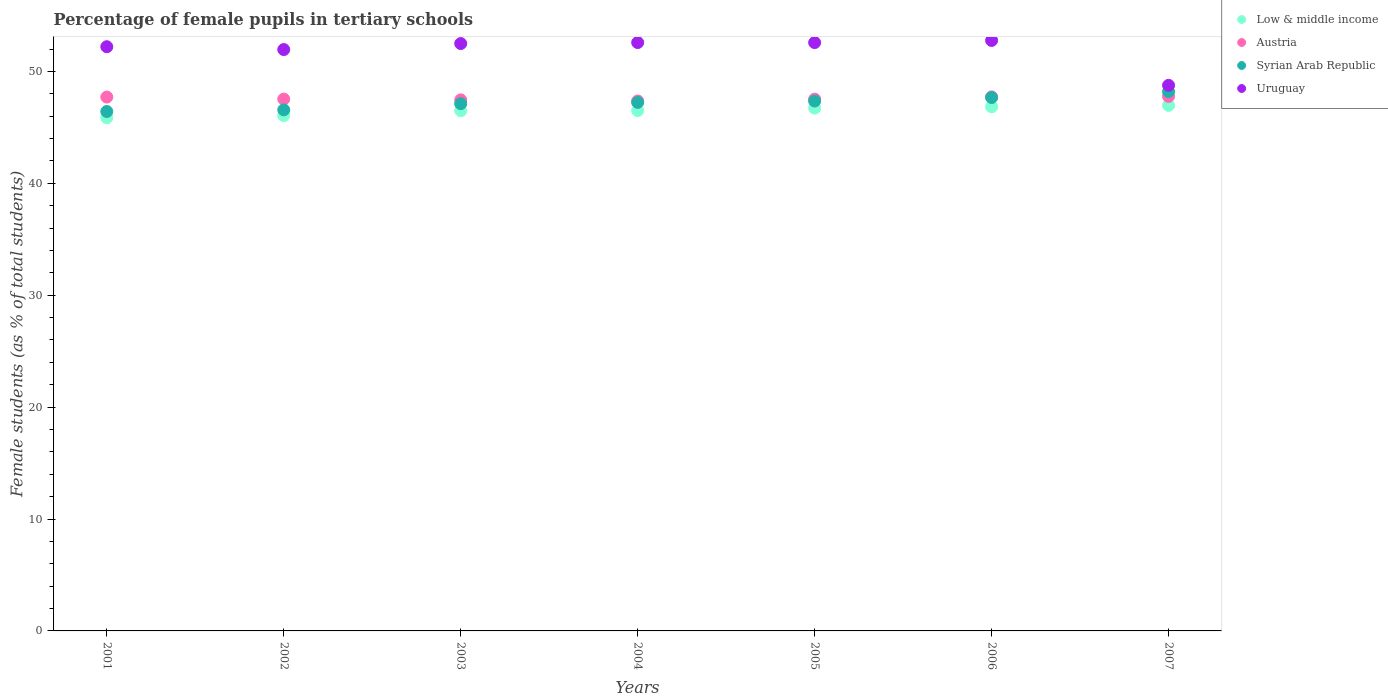Is the number of dotlines equal to the number of legend labels?
Make the answer very short. Yes. What is the percentage of female pupils in tertiary schools in Uruguay in 2005?
Offer a very short reply. 52.58. Across all years, what is the maximum percentage of female pupils in tertiary schools in Low & middle income?
Your answer should be compact. 46.97. Across all years, what is the minimum percentage of female pupils in tertiary schools in Low & middle income?
Provide a succinct answer. 45.87. What is the total percentage of female pupils in tertiary schools in Austria in the graph?
Make the answer very short. 333.08. What is the difference between the percentage of female pupils in tertiary schools in Austria in 2002 and that in 2006?
Make the answer very short. -0.2. What is the difference between the percentage of female pupils in tertiary schools in Syrian Arab Republic in 2006 and the percentage of female pupils in tertiary schools in Uruguay in 2002?
Your answer should be very brief. -4.29. What is the average percentage of female pupils in tertiary schools in Uruguay per year?
Your response must be concise. 51.91. In the year 2001, what is the difference between the percentage of female pupils in tertiary schools in Low & middle income and percentage of female pupils in tertiary schools in Syrian Arab Republic?
Your answer should be compact. -0.55. In how many years, is the percentage of female pupils in tertiary schools in Austria greater than 6 %?
Give a very brief answer. 7. What is the ratio of the percentage of female pupils in tertiary schools in Austria in 2001 to that in 2005?
Your answer should be compact. 1. Is the difference between the percentage of female pupils in tertiary schools in Low & middle income in 2002 and 2004 greater than the difference between the percentage of female pupils in tertiary schools in Syrian Arab Republic in 2002 and 2004?
Offer a very short reply. Yes. What is the difference between the highest and the second highest percentage of female pupils in tertiary schools in Austria?
Provide a short and direct response. 0.04. What is the difference between the highest and the lowest percentage of female pupils in tertiary schools in Syrian Arab Republic?
Give a very brief answer. 1.78. Is it the case that in every year, the sum of the percentage of female pupils in tertiary schools in Low & middle income and percentage of female pupils in tertiary schools in Syrian Arab Republic  is greater than the percentage of female pupils in tertiary schools in Uruguay?
Give a very brief answer. Yes. Is the percentage of female pupils in tertiary schools in Uruguay strictly greater than the percentage of female pupils in tertiary schools in Low & middle income over the years?
Make the answer very short. Yes. Is the percentage of female pupils in tertiary schools in Low & middle income strictly less than the percentage of female pupils in tertiary schools in Syrian Arab Republic over the years?
Keep it short and to the point. Yes. How many dotlines are there?
Give a very brief answer. 4. How many years are there in the graph?
Offer a terse response. 7. What is the difference between two consecutive major ticks on the Y-axis?
Keep it short and to the point. 10. Are the values on the major ticks of Y-axis written in scientific E-notation?
Keep it short and to the point. No. How many legend labels are there?
Offer a very short reply. 4. What is the title of the graph?
Provide a short and direct response. Percentage of female pupils in tertiary schools. Does "Denmark" appear as one of the legend labels in the graph?
Your answer should be very brief. No. What is the label or title of the X-axis?
Your response must be concise. Years. What is the label or title of the Y-axis?
Give a very brief answer. Female students (as % of total students). What is the Female students (as % of total students) of Low & middle income in 2001?
Your response must be concise. 45.87. What is the Female students (as % of total students) in Austria in 2001?
Make the answer very short. 47.71. What is the Female students (as % of total students) of Syrian Arab Republic in 2001?
Your answer should be compact. 46.42. What is the Female students (as % of total students) in Uruguay in 2001?
Offer a terse response. 52.21. What is the Female students (as % of total students) in Low & middle income in 2002?
Provide a succinct answer. 46.06. What is the Female students (as % of total students) of Austria in 2002?
Offer a very short reply. 47.53. What is the Female students (as % of total students) of Syrian Arab Republic in 2002?
Your response must be concise. 46.57. What is the Female students (as % of total students) in Uruguay in 2002?
Ensure brevity in your answer.  51.96. What is the Female students (as % of total students) in Low & middle income in 2003?
Keep it short and to the point. 46.5. What is the Female students (as % of total students) in Austria in 2003?
Provide a succinct answer. 47.46. What is the Female students (as % of total students) of Syrian Arab Republic in 2003?
Ensure brevity in your answer.  47.12. What is the Female students (as % of total students) of Uruguay in 2003?
Give a very brief answer. 52.49. What is the Female students (as % of total students) in Low & middle income in 2004?
Keep it short and to the point. 46.51. What is the Female students (as % of total students) in Austria in 2004?
Your answer should be very brief. 47.36. What is the Female students (as % of total students) of Syrian Arab Republic in 2004?
Make the answer very short. 47.23. What is the Female students (as % of total students) in Uruguay in 2004?
Ensure brevity in your answer.  52.58. What is the Female students (as % of total students) of Low & middle income in 2005?
Your answer should be compact. 46.73. What is the Female students (as % of total students) of Austria in 2005?
Your answer should be very brief. 47.53. What is the Female students (as % of total students) of Syrian Arab Republic in 2005?
Your answer should be very brief. 47.36. What is the Female students (as % of total students) of Uruguay in 2005?
Your response must be concise. 52.58. What is the Female students (as % of total students) of Low & middle income in 2006?
Your answer should be very brief. 46.84. What is the Female students (as % of total students) of Austria in 2006?
Ensure brevity in your answer.  47.72. What is the Female students (as % of total students) of Syrian Arab Republic in 2006?
Give a very brief answer. 47.67. What is the Female students (as % of total students) in Uruguay in 2006?
Your answer should be very brief. 52.77. What is the Female students (as % of total students) of Low & middle income in 2007?
Keep it short and to the point. 46.97. What is the Female students (as % of total students) in Austria in 2007?
Make the answer very short. 47.77. What is the Female students (as % of total students) of Syrian Arab Republic in 2007?
Offer a very short reply. 48.2. What is the Female students (as % of total students) in Uruguay in 2007?
Provide a succinct answer. 48.76. Across all years, what is the maximum Female students (as % of total students) in Low & middle income?
Your answer should be compact. 46.97. Across all years, what is the maximum Female students (as % of total students) of Austria?
Give a very brief answer. 47.77. Across all years, what is the maximum Female students (as % of total students) in Syrian Arab Republic?
Make the answer very short. 48.2. Across all years, what is the maximum Female students (as % of total students) of Uruguay?
Provide a succinct answer. 52.77. Across all years, what is the minimum Female students (as % of total students) in Low & middle income?
Ensure brevity in your answer.  45.87. Across all years, what is the minimum Female students (as % of total students) of Austria?
Offer a terse response. 47.36. Across all years, what is the minimum Female students (as % of total students) of Syrian Arab Republic?
Your response must be concise. 46.42. Across all years, what is the minimum Female students (as % of total students) in Uruguay?
Your response must be concise. 48.76. What is the total Female students (as % of total students) in Low & middle income in the graph?
Your response must be concise. 325.47. What is the total Female students (as % of total students) of Austria in the graph?
Provide a short and direct response. 333.08. What is the total Female students (as % of total students) of Syrian Arab Republic in the graph?
Your response must be concise. 330.56. What is the total Female students (as % of total students) of Uruguay in the graph?
Keep it short and to the point. 363.35. What is the difference between the Female students (as % of total students) in Low & middle income in 2001 and that in 2002?
Ensure brevity in your answer.  -0.19. What is the difference between the Female students (as % of total students) in Austria in 2001 and that in 2002?
Your answer should be compact. 0.18. What is the difference between the Female students (as % of total students) in Syrian Arab Republic in 2001 and that in 2002?
Provide a short and direct response. -0.14. What is the difference between the Female students (as % of total students) of Uruguay in 2001 and that in 2002?
Keep it short and to the point. 0.25. What is the difference between the Female students (as % of total students) of Low & middle income in 2001 and that in 2003?
Ensure brevity in your answer.  -0.63. What is the difference between the Female students (as % of total students) in Austria in 2001 and that in 2003?
Offer a terse response. 0.25. What is the difference between the Female students (as % of total students) of Syrian Arab Republic in 2001 and that in 2003?
Offer a terse response. -0.7. What is the difference between the Female students (as % of total students) in Uruguay in 2001 and that in 2003?
Provide a succinct answer. -0.28. What is the difference between the Female students (as % of total students) in Low & middle income in 2001 and that in 2004?
Give a very brief answer. -0.64. What is the difference between the Female students (as % of total students) of Austria in 2001 and that in 2004?
Keep it short and to the point. 0.35. What is the difference between the Female students (as % of total students) in Syrian Arab Republic in 2001 and that in 2004?
Your answer should be compact. -0.81. What is the difference between the Female students (as % of total students) in Uruguay in 2001 and that in 2004?
Give a very brief answer. -0.37. What is the difference between the Female students (as % of total students) of Low & middle income in 2001 and that in 2005?
Offer a terse response. -0.86. What is the difference between the Female students (as % of total students) in Austria in 2001 and that in 2005?
Your answer should be compact. 0.19. What is the difference between the Female students (as % of total students) of Syrian Arab Republic in 2001 and that in 2005?
Provide a succinct answer. -0.93. What is the difference between the Female students (as % of total students) of Uruguay in 2001 and that in 2005?
Your answer should be very brief. -0.37. What is the difference between the Female students (as % of total students) of Low & middle income in 2001 and that in 2006?
Your answer should be very brief. -0.97. What is the difference between the Female students (as % of total students) in Austria in 2001 and that in 2006?
Keep it short and to the point. -0.01. What is the difference between the Female students (as % of total students) in Syrian Arab Republic in 2001 and that in 2006?
Give a very brief answer. -1.25. What is the difference between the Female students (as % of total students) of Uruguay in 2001 and that in 2006?
Ensure brevity in your answer.  -0.56. What is the difference between the Female students (as % of total students) in Low & middle income in 2001 and that in 2007?
Ensure brevity in your answer.  -1.1. What is the difference between the Female students (as % of total students) of Austria in 2001 and that in 2007?
Offer a terse response. -0.06. What is the difference between the Female students (as % of total students) of Syrian Arab Republic in 2001 and that in 2007?
Keep it short and to the point. -1.78. What is the difference between the Female students (as % of total students) of Uruguay in 2001 and that in 2007?
Provide a short and direct response. 3.45. What is the difference between the Female students (as % of total students) of Low & middle income in 2002 and that in 2003?
Provide a short and direct response. -0.44. What is the difference between the Female students (as % of total students) in Austria in 2002 and that in 2003?
Provide a short and direct response. 0.07. What is the difference between the Female students (as % of total students) in Syrian Arab Republic in 2002 and that in 2003?
Make the answer very short. -0.55. What is the difference between the Female students (as % of total students) of Uruguay in 2002 and that in 2003?
Give a very brief answer. -0.54. What is the difference between the Female students (as % of total students) in Low & middle income in 2002 and that in 2004?
Provide a short and direct response. -0.45. What is the difference between the Female students (as % of total students) in Austria in 2002 and that in 2004?
Your response must be concise. 0.17. What is the difference between the Female students (as % of total students) of Syrian Arab Republic in 2002 and that in 2004?
Give a very brief answer. -0.67. What is the difference between the Female students (as % of total students) of Uruguay in 2002 and that in 2004?
Make the answer very short. -0.63. What is the difference between the Female students (as % of total students) of Low & middle income in 2002 and that in 2005?
Your response must be concise. -0.67. What is the difference between the Female students (as % of total students) of Austria in 2002 and that in 2005?
Offer a very short reply. 0. What is the difference between the Female students (as % of total students) of Syrian Arab Republic in 2002 and that in 2005?
Provide a short and direct response. -0.79. What is the difference between the Female students (as % of total students) of Uruguay in 2002 and that in 2005?
Make the answer very short. -0.62. What is the difference between the Female students (as % of total students) of Low & middle income in 2002 and that in 2006?
Offer a terse response. -0.78. What is the difference between the Female students (as % of total students) in Austria in 2002 and that in 2006?
Give a very brief answer. -0.2. What is the difference between the Female students (as % of total students) of Syrian Arab Republic in 2002 and that in 2006?
Your answer should be compact. -1.1. What is the difference between the Female students (as % of total students) in Uruguay in 2002 and that in 2006?
Ensure brevity in your answer.  -0.82. What is the difference between the Female students (as % of total students) in Low & middle income in 2002 and that in 2007?
Provide a succinct answer. -0.91. What is the difference between the Female students (as % of total students) of Austria in 2002 and that in 2007?
Provide a succinct answer. -0.24. What is the difference between the Female students (as % of total students) of Syrian Arab Republic in 2002 and that in 2007?
Offer a very short reply. -1.63. What is the difference between the Female students (as % of total students) of Uruguay in 2002 and that in 2007?
Provide a succinct answer. 3.2. What is the difference between the Female students (as % of total students) in Low & middle income in 2003 and that in 2004?
Offer a very short reply. -0.01. What is the difference between the Female students (as % of total students) of Austria in 2003 and that in 2004?
Your response must be concise. 0.1. What is the difference between the Female students (as % of total students) in Syrian Arab Republic in 2003 and that in 2004?
Make the answer very short. -0.12. What is the difference between the Female students (as % of total students) in Uruguay in 2003 and that in 2004?
Make the answer very short. -0.09. What is the difference between the Female students (as % of total students) in Low & middle income in 2003 and that in 2005?
Your answer should be very brief. -0.23. What is the difference between the Female students (as % of total students) of Austria in 2003 and that in 2005?
Provide a succinct answer. -0.07. What is the difference between the Female students (as % of total students) in Syrian Arab Republic in 2003 and that in 2005?
Give a very brief answer. -0.24. What is the difference between the Female students (as % of total students) of Uruguay in 2003 and that in 2005?
Your response must be concise. -0.09. What is the difference between the Female students (as % of total students) of Low & middle income in 2003 and that in 2006?
Offer a terse response. -0.35. What is the difference between the Female students (as % of total students) of Austria in 2003 and that in 2006?
Your answer should be compact. -0.27. What is the difference between the Female students (as % of total students) of Syrian Arab Republic in 2003 and that in 2006?
Offer a terse response. -0.55. What is the difference between the Female students (as % of total students) in Uruguay in 2003 and that in 2006?
Provide a succinct answer. -0.28. What is the difference between the Female students (as % of total students) in Low & middle income in 2003 and that in 2007?
Ensure brevity in your answer.  -0.47. What is the difference between the Female students (as % of total students) in Austria in 2003 and that in 2007?
Give a very brief answer. -0.31. What is the difference between the Female students (as % of total students) in Syrian Arab Republic in 2003 and that in 2007?
Your response must be concise. -1.08. What is the difference between the Female students (as % of total students) in Uruguay in 2003 and that in 2007?
Give a very brief answer. 3.73. What is the difference between the Female students (as % of total students) of Low & middle income in 2004 and that in 2005?
Give a very brief answer. -0.22. What is the difference between the Female students (as % of total students) of Austria in 2004 and that in 2005?
Ensure brevity in your answer.  -0.16. What is the difference between the Female students (as % of total students) of Syrian Arab Republic in 2004 and that in 2005?
Your answer should be compact. -0.12. What is the difference between the Female students (as % of total students) of Uruguay in 2004 and that in 2005?
Your response must be concise. 0. What is the difference between the Female students (as % of total students) in Low & middle income in 2004 and that in 2006?
Your answer should be very brief. -0.34. What is the difference between the Female students (as % of total students) in Austria in 2004 and that in 2006?
Your answer should be very brief. -0.36. What is the difference between the Female students (as % of total students) in Syrian Arab Republic in 2004 and that in 2006?
Make the answer very short. -0.43. What is the difference between the Female students (as % of total students) of Uruguay in 2004 and that in 2006?
Your answer should be compact. -0.19. What is the difference between the Female students (as % of total students) in Low & middle income in 2004 and that in 2007?
Provide a short and direct response. -0.46. What is the difference between the Female students (as % of total students) in Austria in 2004 and that in 2007?
Provide a short and direct response. -0.4. What is the difference between the Female students (as % of total students) in Syrian Arab Republic in 2004 and that in 2007?
Offer a terse response. -0.97. What is the difference between the Female students (as % of total students) of Uruguay in 2004 and that in 2007?
Offer a terse response. 3.82. What is the difference between the Female students (as % of total students) in Low & middle income in 2005 and that in 2006?
Provide a short and direct response. -0.12. What is the difference between the Female students (as % of total students) of Austria in 2005 and that in 2006?
Your answer should be very brief. -0.2. What is the difference between the Female students (as % of total students) of Syrian Arab Republic in 2005 and that in 2006?
Ensure brevity in your answer.  -0.31. What is the difference between the Female students (as % of total students) of Uruguay in 2005 and that in 2006?
Provide a short and direct response. -0.19. What is the difference between the Female students (as % of total students) in Low & middle income in 2005 and that in 2007?
Keep it short and to the point. -0.24. What is the difference between the Female students (as % of total students) of Austria in 2005 and that in 2007?
Your answer should be very brief. -0.24. What is the difference between the Female students (as % of total students) of Syrian Arab Republic in 2005 and that in 2007?
Your response must be concise. -0.84. What is the difference between the Female students (as % of total students) in Uruguay in 2005 and that in 2007?
Ensure brevity in your answer.  3.82. What is the difference between the Female students (as % of total students) of Low & middle income in 2006 and that in 2007?
Your response must be concise. -0.12. What is the difference between the Female students (as % of total students) in Austria in 2006 and that in 2007?
Your answer should be compact. -0.04. What is the difference between the Female students (as % of total students) in Syrian Arab Republic in 2006 and that in 2007?
Offer a very short reply. -0.53. What is the difference between the Female students (as % of total students) of Uruguay in 2006 and that in 2007?
Ensure brevity in your answer.  4.01. What is the difference between the Female students (as % of total students) in Low & middle income in 2001 and the Female students (as % of total students) in Austria in 2002?
Provide a succinct answer. -1.66. What is the difference between the Female students (as % of total students) in Low & middle income in 2001 and the Female students (as % of total students) in Syrian Arab Republic in 2002?
Offer a terse response. -0.7. What is the difference between the Female students (as % of total students) in Low & middle income in 2001 and the Female students (as % of total students) in Uruguay in 2002?
Give a very brief answer. -6.09. What is the difference between the Female students (as % of total students) in Austria in 2001 and the Female students (as % of total students) in Syrian Arab Republic in 2002?
Make the answer very short. 1.14. What is the difference between the Female students (as % of total students) in Austria in 2001 and the Female students (as % of total students) in Uruguay in 2002?
Provide a succinct answer. -4.24. What is the difference between the Female students (as % of total students) in Syrian Arab Republic in 2001 and the Female students (as % of total students) in Uruguay in 2002?
Offer a terse response. -5.53. What is the difference between the Female students (as % of total students) of Low & middle income in 2001 and the Female students (as % of total students) of Austria in 2003?
Give a very brief answer. -1.59. What is the difference between the Female students (as % of total students) of Low & middle income in 2001 and the Female students (as % of total students) of Syrian Arab Republic in 2003?
Offer a very short reply. -1.25. What is the difference between the Female students (as % of total students) of Low & middle income in 2001 and the Female students (as % of total students) of Uruguay in 2003?
Your answer should be compact. -6.62. What is the difference between the Female students (as % of total students) of Austria in 2001 and the Female students (as % of total students) of Syrian Arab Republic in 2003?
Provide a succinct answer. 0.59. What is the difference between the Female students (as % of total students) in Austria in 2001 and the Female students (as % of total students) in Uruguay in 2003?
Offer a terse response. -4.78. What is the difference between the Female students (as % of total students) in Syrian Arab Republic in 2001 and the Female students (as % of total students) in Uruguay in 2003?
Offer a terse response. -6.07. What is the difference between the Female students (as % of total students) in Low & middle income in 2001 and the Female students (as % of total students) in Austria in 2004?
Offer a terse response. -1.49. What is the difference between the Female students (as % of total students) of Low & middle income in 2001 and the Female students (as % of total students) of Syrian Arab Republic in 2004?
Provide a short and direct response. -1.36. What is the difference between the Female students (as % of total students) of Low & middle income in 2001 and the Female students (as % of total students) of Uruguay in 2004?
Offer a terse response. -6.71. What is the difference between the Female students (as % of total students) of Austria in 2001 and the Female students (as % of total students) of Syrian Arab Republic in 2004?
Your answer should be very brief. 0.48. What is the difference between the Female students (as % of total students) of Austria in 2001 and the Female students (as % of total students) of Uruguay in 2004?
Ensure brevity in your answer.  -4.87. What is the difference between the Female students (as % of total students) of Syrian Arab Republic in 2001 and the Female students (as % of total students) of Uruguay in 2004?
Offer a terse response. -6.16. What is the difference between the Female students (as % of total students) of Low & middle income in 2001 and the Female students (as % of total students) of Austria in 2005?
Provide a succinct answer. -1.66. What is the difference between the Female students (as % of total students) in Low & middle income in 2001 and the Female students (as % of total students) in Syrian Arab Republic in 2005?
Ensure brevity in your answer.  -1.49. What is the difference between the Female students (as % of total students) of Low & middle income in 2001 and the Female students (as % of total students) of Uruguay in 2005?
Offer a terse response. -6.71. What is the difference between the Female students (as % of total students) of Austria in 2001 and the Female students (as % of total students) of Syrian Arab Republic in 2005?
Make the answer very short. 0.36. What is the difference between the Female students (as % of total students) of Austria in 2001 and the Female students (as % of total students) of Uruguay in 2005?
Provide a succinct answer. -4.87. What is the difference between the Female students (as % of total students) in Syrian Arab Republic in 2001 and the Female students (as % of total students) in Uruguay in 2005?
Make the answer very short. -6.16. What is the difference between the Female students (as % of total students) in Low & middle income in 2001 and the Female students (as % of total students) in Austria in 2006?
Make the answer very short. -1.86. What is the difference between the Female students (as % of total students) of Low & middle income in 2001 and the Female students (as % of total students) of Syrian Arab Republic in 2006?
Offer a terse response. -1.8. What is the difference between the Female students (as % of total students) in Low & middle income in 2001 and the Female students (as % of total students) in Uruguay in 2006?
Keep it short and to the point. -6.9. What is the difference between the Female students (as % of total students) of Austria in 2001 and the Female students (as % of total students) of Syrian Arab Republic in 2006?
Give a very brief answer. 0.04. What is the difference between the Female students (as % of total students) of Austria in 2001 and the Female students (as % of total students) of Uruguay in 2006?
Your answer should be compact. -5.06. What is the difference between the Female students (as % of total students) in Syrian Arab Republic in 2001 and the Female students (as % of total students) in Uruguay in 2006?
Give a very brief answer. -6.35. What is the difference between the Female students (as % of total students) of Low & middle income in 2001 and the Female students (as % of total students) of Austria in 2007?
Offer a terse response. -1.9. What is the difference between the Female students (as % of total students) of Low & middle income in 2001 and the Female students (as % of total students) of Syrian Arab Republic in 2007?
Make the answer very short. -2.33. What is the difference between the Female students (as % of total students) in Low & middle income in 2001 and the Female students (as % of total students) in Uruguay in 2007?
Give a very brief answer. -2.89. What is the difference between the Female students (as % of total students) of Austria in 2001 and the Female students (as % of total students) of Syrian Arab Republic in 2007?
Your answer should be compact. -0.49. What is the difference between the Female students (as % of total students) of Austria in 2001 and the Female students (as % of total students) of Uruguay in 2007?
Keep it short and to the point. -1.05. What is the difference between the Female students (as % of total students) in Syrian Arab Republic in 2001 and the Female students (as % of total students) in Uruguay in 2007?
Make the answer very short. -2.34. What is the difference between the Female students (as % of total students) in Low & middle income in 2002 and the Female students (as % of total students) in Austria in 2003?
Your response must be concise. -1.4. What is the difference between the Female students (as % of total students) of Low & middle income in 2002 and the Female students (as % of total students) of Syrian Arab Republic in 2003?
Provide a succinct answer. -1.06. What is the difference between the Female students (as % of total students) in Low & middle income in 2002 and the Female students (as % of total students) in Uruguay in 2003?
Your answer should be compact. -6.43. What is the difference between the Female students (as % of total students) in Austria in 2002 and the Female students (as % of total students) in Syrian Arab Republic in 2003?
Provide a short and direct response. 0.41. What is the difference between the Female students (as % of total students) of Austria in 2002 and the Female students (as % of total students) of Uruguay in 2003?
Ensure brevity in your answer.  -4.96. What is the difference between the Female students (as % of total students) in Syrian Arab Republic in 2002 and the Female students (as % of total students) in Uruguay in 2003?
Your answer should be very brief. -5.93. What is the difference between the Female students (as % of total students) in Low & middle income in 2002 and the Female students (as % of total students) in Austria in 2004?
Your answer should be compact. -1.3. What is the difference between the Female students (as % of total students) of Low & middle income in 2002 and the Female students (as % of total students) of Syrian Arab Republic in 2004?
Your response must be concise. -1.17. What is the difference between the Female students (as % of total students) in Low & middle income in 2002 and the Female students (as % of total students) in Uruguay in 2004?
Keep it short and to the point. -6.52. What is the difference between the Female students (as % of total students) of Austria in 2002 and the Female students (as % of total students) of Syrian Arab Republic in 2004?
Make the answer very short. 0.3. What is the difference between the Female students (as % of total students) in Austria in 2002 and the Female students (as % of total students) in Uruguay in 2004?
Your answer should be very brief. -5.05. What is the difference between the Female students (as % of total students) in Syrian Arab Republic in 2002 and the Female students (as % of total students) in Uruguay in 2004?
Your answer should be very brief. -6.02. What is the difference between the Female students (as % of total students) of Low & middle income in 2002 and the Female students (as % of total students) of Austria in 2005?
Offer a terse response. -1.47. What is the difference between the Female students (as % of total students) in Low & middle income in 2002 and the Female students (as % of total students) in Syrian Arab Republic in 2005?
Provide a short and direct response. -1.3. What is the difference between the Female students (as % of total students) in Low & middle income in 2002 and the Female students (as % of total students) in Uruguay in 2005?
Your answer should be very brief. -6.52. What is the difference between the Female students (as % of total students) in Austria in 2002 and the Female students (as % of total students) in Syrian Arab Republic in 2005?
Offer a terse response. 0.17. What is the difference between the Female students (as % of total students) of Austria in 2002 and the Female students (as % of total students) of Uruguay in 2005?
Keep it short and to the point. -5.05. What is the difference between the Female students (as % of total students) in Syrian Arab Republic in 2002 and the Female students (as % of total students) in Uruguay in 2005?
Your response must be concise. -6.01. What is the difference between the Female students (as % of total students) in Low & middle income in 2002 and the Female students (as % of total students) in Austria in 2006?
Offer a very short reply. -1.67. What is the difference between the Female students (as % of total students) in Low & middle income in 2002 and the Female students (as % of total students) in Syrian Arab Republic in 2006?
Keep it short and to the point. -1.61. What is the difference between the Female students (as % of total students) of Low & middle income in 2002 and the Female students (as % of total students) of Uruguay in 2006?
Keep it short and to the point. -6.71. What is the difference between the Female students (as % of total students) in Austria in 2002 and the Female students (as % of total students) in Syrian Arab Republic in 2006?
Your answer should be compact. -0.14. What is the difference between the Female students (as % of total students) in Austria in 2002 and the Female students (as % of total students) in Uruguay in 2006?
Keep it short and to the point. -5.24. What is the difference between the Female students (as % of total students) in Syrian Arab Republic in 2002 and the Female students (as % of total students) in Uruguay in 2006?
Your answer should be compact. -6.21. What is the difference between the Female students (as % of total students) of Low & middle income in 2002 and the Female students (as % of total students) of Austria in 2007?
Your answer should be compact. -1.71. What is the difference between the Female students (as % of total students) of Low & middle income in 2002 and the Female students (as % of total students) of Syrian Arab Republic in 2007?
Offer a terse response. -2.14. What is the difference between the Female students (as % of total students) of Low & middle income in 2002 and the Female students (as % of total students) of Uruguay in 2007?
Keep it short and to the point. -2.7. What is the difference between the Female students (as % of total students) of Austria in 2002 and the Female students (as % of total students) of Syrian Arab Republic in 2007?
Provide a succinct answer. -0.67. What is the difference between the Female students (as % of total students) in Austria in 2002 and the Female students (as % of total students) in Uruguay in 2007?
Provide a short and direct response. -1.23. What is the difference between the Female students (as % of total students) in Syrian Arab Republic in 2002 and the Female students (as % of total students) in Uruguay in 2007?
Offer a terse response. -2.19. What is the difference between the Female students (as % of total students) in Low & middle income in 2003 and the Female students (as % of total students) in Austria in 2004?
Provide a short and direct response. -0.87. What is the difference between the Female students (as % of total students) in Low & middle income in 2003 and the Female students (as % of total students) in Syrian Arab Republic in 2004?
Provide a short and direct response. -0.74. What is the difference between the Female students (as % of total students) of Low & middle income in 2003 and the Female students (as % of total students) of Uruguay in 2004?
Keep it short and to the point. -6.09. What is the difference between the Female students (as % of total students) of Austria in 2003 and the Female students (as % of total students) of Syrian Arab Republic in 2004?
Your response must be concise. 0.23. What is the difference between the Female students (as % of total students) of Austria in 2003 and the Female students (as % of total students) of Uruguay in 2004?
Make the answer very short. -5.12. What is the difference between the Female students (as % of total students) of Syrian Arab Republic in 2003 and the Female students (as % of total students) of Uruguay in 2004?
Give a very brief answer. -5.47. What is the difference between the Female students (as % of total students) in Low & middle income in 2003 and the Female students (as % of total students) in Austria in 2005?
Provide a succinct answer. -1.03. What is the difference between the Female students (as % of total students) in Low & middle income in 2003 and the Female students (as % of total students) in Syrian Arab Republic in 2005?
Your answer should be very brief. -0.86. What is the difference between the Female students (as % of total students) in Low & middle income in 2003 and the Female students (as % of total students) in Uruguay in 2005?
Your answer should be very brief. -6.08. What is the difference between the Female students (as % of total students) in Austria in 2003 and the Female students (as % of total students) in Syrian Arab Republic in 2005?
Your answer should be very brief. 0.1. What is the difference between the Female students (as % of total students) in Austria in 2003 and the Female students (as % of total students) in Uruguay in 2005?
Offer a terse response. -5.12. What is the difference between the Female students (as % of total students) in Syrian Arab Republic in 2003 and the Female students (as % of total students) in Uruguay in 2005?
Make the answer very short. -5.46. What is the difference between the Female students (as % of total students) in Low & middle income in 2003 and the Female students (as % of total students) in Austria in 2006?
Your response must be concise. -1.23. What is the difference between the Female students (as % of total students) in Low & middle income in 2003 and the Female students (as % of total students) in Syrian Arab Republic in 2006?
Your answer should be very brief. -1.17. What is the difference between the Female students (as % of total students) of Low & middle income in 2003 and the Female students (as % of total students) of Uruguay in 2006?
Your answer should be very brief. -6.28. What is the difference between the Female students (as % of total students) of Austria in 2003 and the Female students (as % of total students) of Syrian Arab Republic in 2006?
Your response must be concise. -0.21. What is the difference between the Female students (as % of total students) of Austria in 2003 and the Female students (as % of total students) of Uruguay in 2006?
Your answer should be very brief. -5.31. What is the difference between the Female students (as % of total students) in Syrian Arab Republic in 2003 and the Female students (as % of total students) in Uruguay in 2006?
Provide a short and direct response. -5.65. What is the difference between the Female students (as % of total students) of Low & middle income in 2003 and the Female students (as % of total students) of Austria in 2007?
Your answer should be very brief. -1.27. What is the difference between the Female students (as % of total students) in Low & middle income in 2003 and the Female students (as % of total students) in Syrian Arab Republic in 2007?
Your answer should be very brief. -1.7. What is the difference between the Female students (as % of total students) in Low & middle income in 2003 and the Female students (as % of total students) in Uruguay in 2007?
Give a very brief answer. -2.26. What is the difference between the Female students (as % of total students) in Austria in 2003 and the Female students (as % of total students) in Syrian Arab Republic in 2007?
Offer a very short reply. -0.74. What is the difference between the Female students (as % of total students) of Austria in 2003 and the Female students (as % of total students) of Uruguay in 2007?
Offer a terse response. -1.3. What is the difference between the Female students (as % of total students) of Syrian Arab Republic in 2003 and the Female students (as % of total students) of Uruguay in 2007?
Make the answer very short. -1.64. What is the difference between the Female students (as % of total students) in Low & middle income in 2004 and the Female students (as % of total students) in Austria in 2005?
Give a very brief answer. -1.02. What is the difference between the Female students (as % of total students) of Low & middle income in 2004 and the Female students (as % of total students) of Syrian Arab Republic in 2005?
Your response must be concise. -0.85. What is the difference between the Female students (as % of total students) of Low & middle income in 2004 and the Female students (as % of total students) of Uruguay in 2005?
Offer a terse response. -6.07. What is the difference between the Female students (as % of total students) in Austria in 2004 and the Female students (as % of total students) in Syrian Arab Republic in 2005?
Offer a terse response. 0.01. What is the difference between the Female students (as % of total students) of Austria in 2004 and the Female students (as % of total students) of Uruguay in 2005?
Ensure brevity in your answer.  -5.22. What is the difference between the Female students (as % of total students) in Syrian Arab Republic in 2004 and the Female students (as % of total students) in Uruguay in 2005?
Your response must be concise. -5.35. What is the difference between the Female students (as % of total students) of Low & middle income in 2004 and the Female students (as % of total students) of Austria in 2006?
Offer a terse response. -1.22. What is the difference between the Female students (as % of total students) in Low & middle income in 2004 and the Female students (as % of total students) in Syrian Arab Republic in 2006?
Make the answer very short. -1.16. What is the difference between the Female students (as % of total students) in Low & middle income in 2004 and the Female students (as % of total students) in Uruguay in 2006?
Keep it short and to the point. -6.27. What is the difference between the Female students (as % of total students) in Austria in 2004 and the Female students (as % of total students) in Syrian Arab Republic in 2006?
Your answer should be very brief. -0.3. What is the difference between the Female students (as % of total students) of Austria in 2004 and the Female students (as % of total students) of Uruguay in 2006?
Your answer should be compact. -5.41. What is the difference between the Female students (as % of total students) in Syrian Arab Republic in 2004 and the Female students (as % of total students) in Uruguay in 2006?
Your answer should be compact. -5.54. What is the difference between the Female students (as % of total students) of Low & middle income in 2004 and the Female students (as % of total students) of Austria in 2007?
Provide a short and direct response. -1.26. What is the difference between the Female students (as % of total students) in Low & middle income in 2004 and the Female students (as % of total students) in Syrian Arab Republic in 2007?
Your answer should be very brief. -1.69. What is the difference between the Female students (as % of total students) of Low & middle income in 2004 and the Female students (as % of total students) of Uruguay in 2007?
Give a very brief answer. -2.25. What is the difference between the Female students (as % of total students) of Austria in 2004 and the Female students (as % of total students) of Syrian Arab Republic in 2007?
Your answer should be very brief. -0.84. What is the difference between the Female students (as % of total students) of Austria in 2004 and the Female students (as % of total students) of Uruguay in 2007?
Give a very brief answer. -1.4. What is the difference between the Female students (as % of total students) of Syrian Arab Republic in 2004 and the Female students (as % of total students) of Uruguay in 2007?
Give a very brief answer. -1.53. What is the difference between the Female students (as % of total students) of Low & middle income in 2005 and the Female students (as % of total students) of Austria in 2006?
Ensure brevity in your answer.  -1. What is the difference between the Female students (as % of total students) in Low & middle income in 2005 and the Female students (as % of total students) in Syrian Arab Republic in 2006?
Your answer should be compact. -0.94. What is the difference between the Female students (as % of total students) of Low & middle income in 2005 and the Female students (as % of total students) of Uruguay in 2006?
Provide a succinct answer. -6.04. What is the difference between the Female students (as % of total students) in Austria in 2005 and the Female students (as % of total students) in Syrian Arab Republic in 2006?
Ensure brevity in your answer.  -0.14. What is the difference between the Female students (as % of total students) of Austria in 2005 and the Female students (as % of total students) of Uruguay in 2006?
Offer a very short reply. -5.25. What is the difference between the Female students (as % of total students) in Syrian Arab Republic in 2005 and the Female students (as % of total students) in Uruguay in 2006?
Your response must be concise. -5.42. What is the difference between the Female students (as % of total students) of Low & middle income in 2005 and the Female students (as % of total students) of Austria in 2007?
Your answer should be very brief. -1.04. What is the difference between the Female students (as % of total students) in Low & middle income in 2005 and the Female students (as % of total students) in Syrian Arab Republic in 2007?
Your response must be concise. -1.47. What is the difference between the Female students (as % of total students) of Low & middle income in 2005 and the Female students (as % of total students) of Uruguay in 2007?
Keep it short and to the point. -2.03. What is the difference between the Female students (as % of total students) in Austria in 2005 and the Female students (as % of total students) in Syrian Arab Republic in 2007?
Provide a short and direct response. -0.67. What is the difference between the Female students (as % of total students) of Austria in 2005 and the Female students (as % of total students) of Uruguay in 2007?
Make the answer very short. -1.23. What is the difference between the Female students (as % of total students) in Syrian Arab Republic in 2005 and the Female students (as % of total students) in Uruguay in 2007?
Offer a very short reply. -1.4. What is the difference between the Female students (as % of total students) in Low & middle income in 2006 and the Female students (as % of total students) in Austria in 2007?
Your answer should be compact. -0.92. What is the difference between the Female students (as % of total students) in Low & middle income in 2006 and the Female students (as % of total students) in Syrian Arab Republic in 2007?
Offer a terse response. -1.36. What is the difference between the Female students (as % of total students) in Low & middle income in 2006 and the Female students (as % of total students) in Uruguay in 2007?
Keep it short and to the point. -1.92. What is the difference between the Female students (as % of total students) of Austria in 2006 and the Female students (as % of total students) of Syrian Arab Republic in 2007?
Provide a succinct answer. -0.48. What is the difference between the Female students (as % of total students) in Austria in 2006 and the Female students (as % of total students) in Uruguay in 2007?
Ensure brevity in your answer.  -1.03. What is the difference between the Female students (as % of total students) in Syrian Arab Republic in 2006 and the Female students (as % of total students) in Uruguay in 2007?
Provide a succinct answer. -1.09. What is the average Female students (as % of total students) in Low & middle income per year?
Your response must be concise. 46.5. What is the average Female students (as % of total students) of Austria per year?
Your answer should be compact. 47.58. What is the average Female students (as % of total students) of Syrian Arab Republic per year?
Your answer should be very brief. 47.22. What is the average Female students (as % of total students) in Uruguay per year?
Your response must be concise. 51.91. In the year 2001, what is the difference between the Female students (as % of total students) of Low & middle income and Female students (as % of total students) of Austria?
Make the answer very short. -1.84. In the year 2001, what is the difference between the Female students (as % of total students) of Low & middle income and Female students (as % of total students) of Syrian Arab Republic?
Offer a terse response. -0.55. In the year 2001, what is the difference between the Female students (as % of total students) of Low & middle income and Female students (as % of total students) of Uruguay?
Make the answer very short. -6.34. In the year 2001, what is the difference between the Female students (as % of total students) in Austria and Female students (as % of total students) in Syrian Arab Republic?
Make the answer very short. 1.29. In the year 2001, what is the difference between the Female students (as % of total students) of Austria and Female students (as % of total students) of Uruguay?
Make the answer very short. -4.5. In the year 2001, what is the difference between the Female students (as % of total students) in Syrian Arab Republic and Female students (as % of total students) in Uruguay?
Offer a terse response. -5.79. In the year 2002, what is the difference between the Female students (as % of total students) in Low & middle income and Female students (as % of total students) in Austria?
Offer a very short reply. -1.47. In the year 2002, what is the difference between the Female students (as % of total students) in Low & middle income and Female students (as % of total students) in Syrian Arab Republic?
Offer a terse response. -0.51. In the year 2002, what is the difference between the Female students (as % of total students) in Low & middle income and Female students (as % of total students) in Uruguay?
Your answer should be very brief. -5.9. In the year 2002, what is the difference between the Female students (as % of total students) in Austria and Female students (as % of total students) in Syrian Arab Republic?
Provide a short and direct response. 0.96. In the year 2002, what is the difference between the Female students (as % of total students) of Austria and Female students (as % of total students) of Uruguay?
Offer a terse response. -4.43. In the year 2002, what is the difference between the Female students (as % of total students) in Syrian Arab Republic and Female students (as % of total students) in Uruguay?
Keep it short and to the point. -5.39. In the year 2003, what is the difference between the Female students (as % of total students) in Low & middle income and Female students (as % of total students) in Austria?
Keep it short and to the point. -0.96. In the year 2003, what is the difference between the Female students (as % of total students) of Low & middle income and Female students (as % of total students) of Syrian Arab Republic?
Give a very brief answer. -0.62. In the year 2003, what is the difference between the Female students (as % of total students) in Low & middle income and Female students (as % of total students) in Uruguay?
Keep it short and to the point. -6. In the year 2003, what is the difference between the Female students (as % of total students) of Austria and Female students (as % of total students) of Syrian Arab Republic?
Give a very brief answer. 0.34. In the year 2003, what is the difference between the Female students (as % of total students) in Austria and Female students (as % of total students) in Uruguay?
Your answer should be compact. -5.03. In the year 2003, what is the difference between the Female students (as % of total students) of Syrian Arab Republic and Female students (as % of total students) of Uruguay?
Your response must be concise. -5.38. In the year 2004, what is the difference between the Female students (as % of total students) of Low & middle income and Female students (as % of total students) of Austria?
Give a very brief answer. -0.86. In the year 2004, what is the difference between the Female students (as % of total students) in Low & middle income and Female students (as % of total students) in Syrian Arab Republic?
Provide a succinct answer. -0.73. In the year 2004, what is the difference between the Female students (as % of total students) in Low & middle income and Female students (as % of total students) in Uruguay?
Provide a succinct answer. -6.08. In the year 2004, what is the difference between the Female students (as % of total students) of Austria and Female students (as % of total students) of Syrian Arab Republic?
Offer a terse response. 0.13. In the year 2004, what is the difference between the Female students (as % of total students) of Austria and Female students (as % of total students) of Uruguay?
Make the answer very short. -5.22. In the year 2004, what is the difference between the Female students (as % of total students) in Syrian Arab Republic and Female students (as % of total students) in Uruguay?
Your response must be concise. -5.35. In the year 2005, what is the difference between the Female students (as % of total students) in Low & middle income and Female students (as % of total students) in Austria?
Offer a very short reply. -0.8. In the year 2005, what is the difference between the Female students (as % of total students) of Low & middle income and Female students (as % of total students) of Syrian Arab Republic?
Offer a terse response. -0.63. In the year 2005, what is the difference between the Female students (as % of total students) of Low & middle income and Female students (as % of total students) of Uruguay?
Your response must be concise. -5.85. In the year 2005, what is the difference between the Female students (as % of total students) in Austria and Female students (as % of total students) in Syrian Arab Republic?
Ensure brevity in your answer.  0.17. In the year 2005, what is the difference between the Female students (as % of total students) of Austria and Female students (as % of total students) of Uruguay?
Your answer should be very brief. -5.05. In the year 2005, what is the difference between the Female students (as % of total students) in Syrian Arab Republic and Female students (as % of total students) in Uruguay?
Your answer should be compact. -5.22. In the year 2006, what is the difference between the Female students (as % of total students) of Low & middle income and Female students (as % of total students) of Austria?
Keep it short and to the point. -0.88. In the year 2006, what is the difference between the Female students (as % of total students) of Low & middle income and Female students (as % of total students) of Syrian Arab Republic?
Offer a terse response. -0.82. In the year 2006, what is the difference between the Female students (as % of total students) of Low & middle income and Female students (as % of total students) of Uruguay?
Keep it short and to the point. -5.93. In the year 2006, what is the difference between the Female students (as % of total students) in Austria and Female students (as % of total students) in Syrian Arab Republic?
Make the answer very short. 0.06. In the year 2006, what is the difference between the Female students (as % of total students) of Austria and Female students (as % of total students) of Uruguay?
Offer a very short reply. -5.05. In the year 2006, what is the difference between the Female students (as % of total students) of Syrian Arab Republic and Female students (as % of total students) of Uruguay?
Your response must be concise. -5.1. In the year 2007, what is the difference between the Female students (as % of total students) of Low & middle income and Female students (as % of total students) of Austria?
Your answer should be compact. -0.8. In the year 2007, what is the difference between the Female students (as % of total students) of Low & middle income and Female students (as % of total students) of Syrian Arab Republic?
Your response must be concise. -1.23. In the year 2007, what is the difference between the Female students (as % of total students) in Low & middle income and Female students (as % of total students) in Uruguay?
Provide a short and direct response. -1.79. In the year 2007, what is the difference between the Female students (as % of total students) in Austria and Female students (as % of total students) in Syrian Arab Republic?
Your response must be concise. -0.43. In the year 2007, what is the difference between the Female students (as % of total students) of Austria and Female students (as % of total students) of Uruguay?
Provide a succinct answer. -0.99. In the year 2007, what is the difference between the Female students (as % of total students) of Syrian Arab Republic and Female students (as % of total students) of Uruguay?
Your answer should be very brief. -0.56. What is the ratio of the Female students (as % of total students) in Austria in 2001 to that in 2002?
Your answer should be compact. 1. What is the ratio of the Female students (as % of total students) in Syrian Arab Republic in 2001 to that in 2002?
Keep it short and to the point. 1. What is the ratio of the Female students (as % of total students) in Uruguay in 2001 to that in 2002?
Keep it short and to the point. 1. What is the ratio of the Female students (as % of total students) of Low & middle income in 2001 to that in 2003?
Offer a terse response. 0.99. What is the ratio of the Female students (as % of total students) in Syrian Arab Republic in 2001 to that in 2003?
Make the answer very short. 0.99. What is the ratio of the Female students (as % of total students) in Uruguay in 2001 to that in 2003?
Give a very brief answer. 0.99. What is the ratio of the Female students (as % of total students) in Low & middle income in 2001 to that in 2004?
Keep it short and to the point. 0.99. What is the ratio of the Female students (as % of total students) of Austria in 2001 to that in 2004?
Offer a terse response. 1.01. What is the ratio of the Female students (as % of total students) in Syrian Arab Republic in 2001 to that in 2004?
Offer a very short reply. 0.98. What is the ratio of the Female students (as % of total students) in Low & middle income in 2001 to that in 2005?
Give a very brief answer. 0.98. What is the ratio of the Female students (as % of total students) of Syrian Arab Republic in 2001 to that in 2005?
Offer a terse response. 0.98. What is the ratio of the Female students (as % of total students) of Uruguay in 2001 to that in 2005?
Make the answer very short. 0.99. What is the ratio of the Female students (as % of total students) of Low & middle income in 2001 to that in 2006?
Ensure brevity in your answer.  0.98. What is the ratio of the Female students (as % of total students) in Syrian Arab Republic in 2001 to that in 2006?
Offer a terse response. 0.97. What is the ratio of the Female students (as % of total students) in Low & middle income in 2001 to that in 2007?
Your answer should be compact. 0.98. What is the ratio of the Female students (as % of total students) in Syrian Arab Republic in 2001 to that in 2007?
Provide a succinct answer. 0.96. What is the ratio of the Female students (as % of total students) in Uruguay in 2001 to that in 2007?
Provide a short and direct response. 1.07. What is the ratio of the Female students (as % of total students) of Low & middle income in 2002 to that in 2003?
Provide a short and direct response. 0.99. What is the ratio of the Female students (as % of total students) in Syrian Arab Republic in 2002 to that in 2003?
Ensure brevity in your answer.  0.99. What is the ratio of the Female students (as % of total students) of Uruguay in 2002 to that in 2003?
Offer a terse response. 0.99. What is the ratio of the Female students (as % of total students) of Austria in 2002 to that in 2004?
Provide a succinct answer. 1. What is the ratio of the Female students (as % of total students) in Syrian Arab Republic in 2002 to that in 2004?
Keep it short and to the point. 0.99. What is the ratio of the Female students (as % of total students) of Uruguay in 2002 to that in 2004?
Provide a short and direct response. 0.99. What is the ratio of the Female students (as % of total students) of Low & middle income in 2002 to that in 2005?
Offer a very short reply. 0.99. What is the ratio of the Female students (as % of total students) in Austria in 2002 to that in 2005?
Make the answer very short. 1. What is the ratio of the Female students (as % of total students) of Syrian Arab Republic in 2002 to that in 2005?
Offer a very short reply. 0.98. What is the ratio of the Female students (as % of total students) in Uruguay in 2002 to that in 2005?
Your answer should be very brief. 0.99. What is the ratio of the Female students (as % of total students) of Low & middle income in 2002 to that in 2006?
Give a very brief answer. 0.98. What is the ratio of the Female students (as % of total students) of Syrian Arab Republic in 2002 to that in 2006?
Offer a very short reply. 0.98. What is the ratio of the Female students (as % of total students) in Uruguay in 2002 to that in 2006?
Give a very brief answer. 0.98. What is the ratio of the Female students (as % of total students) in Low & middle income in 2002 to that in 2007?
Make the answer very short. 0.98. What is the ratio of the Female students (as % of total students) in Syrian Arab Republic in 2002 to that in 2007?
Offer a very short reply. 0.97. What is the ratio of the Female students (as % of total students) of Uruguay in 2002 to that in 2007?
Offer a terse response. 1.07. What is the ratio of the Female students (as % of total students) in Syrian Arab Republic in 2003 to that in 2004?
Keep it short and to the point. 1. What is the ratio of the Female students (as % of total students) in Austria in 2003 to that in 2005?
Ensure brevity in your answer.  1. What is the ratio of the Female students (as % of total students) of Syrian Arab Republic in 2003 to that in 2005?
Make the answer very short. 0.99. What is the ratio of the Female students (as % of total students) of Austria in 2003 to that in 2007?
Provide a short and direct response. 0.99. What is the ratio of the Female students (as % of total students) of Syrian Arab Republic in 2003 to that in 2007?
Your answer should be compact. 0.98. What is the ratio of the Female students (as % of total students) in Uruguay in 2003 to that in 2007?
Keep it short and to the point. 1.08. What is the ratio of the Female students (as % of total students) in Low & middle income in 2004 to that in 2005?
Offer a very short reply. 1. What is the ratio of the Female students (as % of total students) of Syrian Arab Republic in 2004 to that in 2005?
Offer a terse response. 1. What is the ratio of the Female students (as % of total students) of Syrian Arab Republic in 2004 to that in 2006?
Provide a short and direct response. 0.99. What is the ratio of the Female students (as % of total students) of Uruguay in 2004 to that in 2006?
Ensure brevity in your answer.  1. What is the ratio of the Female students (as % of total students) in Low & middle income in 2004 to that in 2007?
Give a very brief answer. 0.99. What is the ratio of the Female students (as % of total students) of Syrian Arab Republic in 2004 to that in 2007?
Give a very brief answer. 0.98. What is the ratio of the Female students (as % of total students) in Uruguay in 2004 to that in 2007?
Offer a very short reply. 1.08. What is the ratio of the Female students (as % of total students) in Low & middle income in 2005 to that in 2006?
Keep it short and to the point. 1. What is the ratio of the Female students (as % of total students) in Austria in 2005 to that in 2006?
Your response must be concise. 1. What is the ratio of the Female students (as % of total students) of Uruguay in 2005 to that in 2006?
Your answer should be very brief. 1. What is the ratio of the Female students (as % of total students) in Low & middle income in 2005 to that in 2007?
Your answer should be compact. 0.99. What is the ratio of the Female students (as % of total students) of Austria in 2005 to that in 2007?
Your answer should be compact. 0.99. What is the ratio of the Female students (as % of total students) of Syrian Arab Republic in 2005 to that in 2007?
Keep it short and to the point. 0.98. What is the ratio of the Female students (as % of total students) in Uruguay in 2005 to that in 2007?
Provide a short and direct response. 1.08. What is the ratio of the Female students (as % of total students) of Syrian Arab Republic in 2006 to that in 2007?
Your response must be concise. 0.99. What is the ratio of the Female students (as % of total students) of Uruguay in 2006 to that in 2007?
Make the answer very short. 1.08. What is the difference between the highest and the second highest Female students (as % of total students) of Low & middle income?
Provide a short and direct response. 0.12. What is the difference between the highest and the second highest Female students (as % of total students) of Austria?
Give a very brief answer. 0.04. What is the difference between the highest and the second highest Female students (as % of total students) of Syrian Arab Republic?
Your response must be concise. 0.53. What is the difference between the highest and the second highest Female students (as % of total students) in Uruguay?
Make the answer very short. 0.19. What is the difference between the highest and the lowest Female students (as % of total students) of Low & middle income?
Ensure brevity in your answer.  1.1. What is the difference between the highest and the lowest Female students (as % of total students) of Austria?
Your response must be concise. 0.4. What is the difference between the highest and the lowest Female students (as % of total students) of Syrian Arab Republic?
Give a very brief answer. 1.78. What is the difference between the highest and the lowest Female students (as % of total students) of Uruguay?
Offer a terse response. 4.01. 